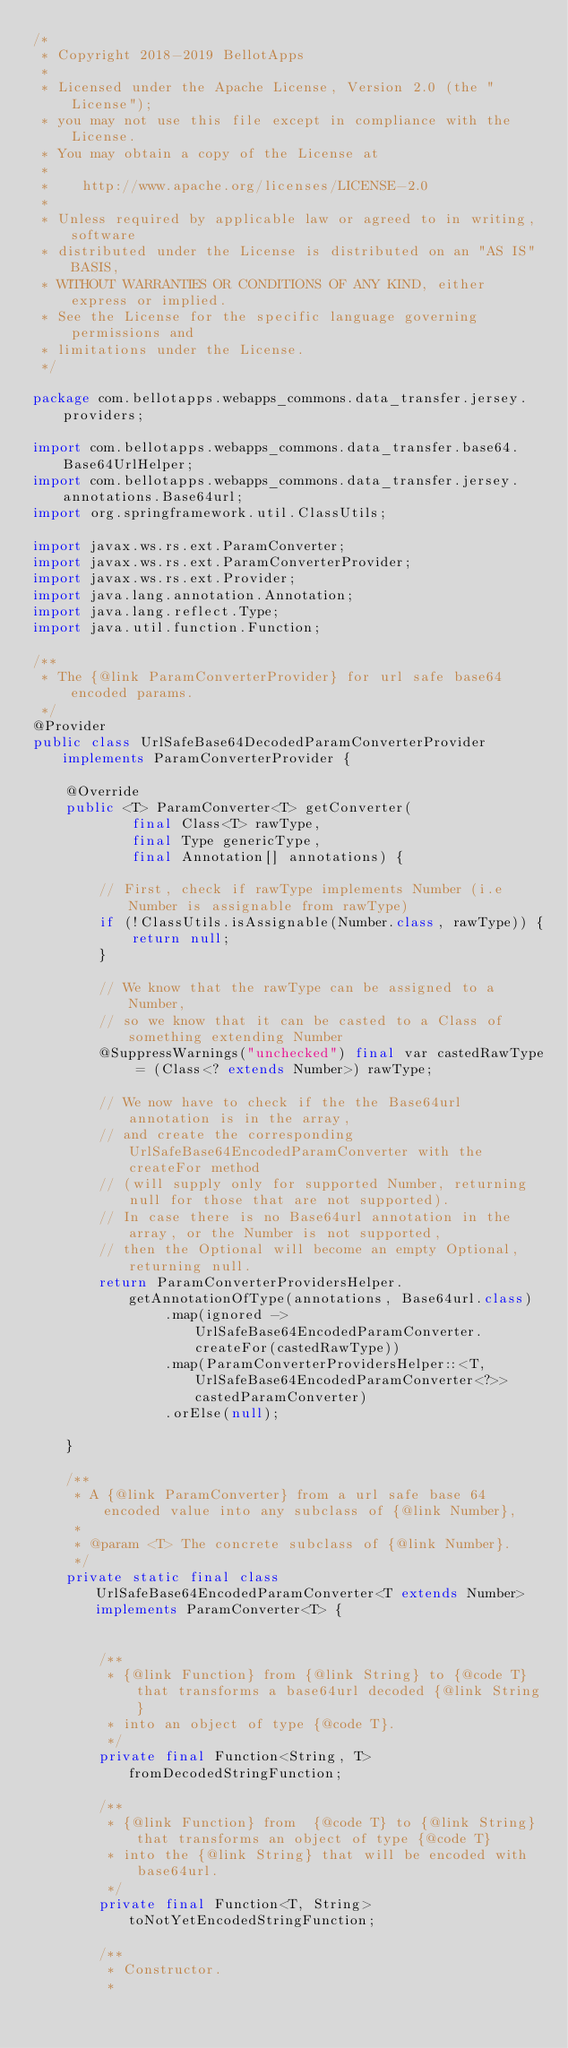<code> <loc_0><loc_0><loc_500><loc_500><_Java_>/*
 * Copyright 2018-2019 BellotApps
 *
 * Licensed under the Apache License, Version 2.0 (the "License");
 * you may not use this file except in compliance with the License.
 * You may obtain a copy of the License at
 *
 *    http://www.apache.org/licenses/LICENSE-2.0
 *
 * Unless required by applicable law or agreed to in writing, software
 * distributed under the License is distributed on an "AS IS" BASIS,
 * WITHOUT WARRANTIES OR CONDITIONS OF ANY KIND, either express or implied.
 * See the License for the specific language governing permissions and
 * limitations under the License.
 */

package com.bellotapps.webapps_commons.data_transfer.jersey.providers;

import com.bellotapps.webapps_commons.data_transfer.base64.Base64UrlHelper;
import com.bellotapps.webapps_commons.data_transfer.jersey.annotations.Base64url;
import org.springframework.util.ClassUtils;

import javax.ws.rs.ext.ParamConverter;
import javax.ws.rs.ext.ParamConverterProvider;
import javax.ws.rs.ext.Provider;
import java.lang.annotation.Annotation;
import java.lang.reflect.Type;
import java.util.function.Function;

/**
 * The {@link ParamConverterProvider} for url safe base64 encoded params.
 */
@Provider
public class UrlSafeBase64DecodedParamConverterProvider implements ParamConverterProvider {

    @Override
    public <T> ParamConverter<T> getConverter(
            final Class<T> rawType,
            final Type genericType,
            final Annotation[] annotations) {

        // First, check if rawType implements Number (i.e Number is assignable from rawType)
        if (!ClassUtils.isAssignable(Number.class, rawType)) {
            return null;
        }

        // We know that the rawType can be assigned to a Number,
        // so we know that it can be casted to a Class of something extending Number
        @SuppressWarnings("unchecked") final var castedRawType = (Class<? extends Number>) rawType;

        // We now have to check if the the Base64url annotation is in the array,
        // and create the corresponding UrlSafeBase64EncodedParamConverter with the createFor method
        // (will supply only for supported Number, returning null for those that are not supported).
        // In case there is no Base64url annotation in the array, or the Number is not supported,
        // then the Optional will become an empty Optional, returning null.
        return ParamConverterProvidersHelper.getAnnotationOfType(annotations, Base64url.class)
                .map(ignored -> UrlSafeBase64EncodedParamConverter.createFor(castedRawType))
                .map(ParamConverterProvidersHelper::<T, UrlSafeBase64EncodedParamConverter<?>>castedParamConverter)
                .orElse(null);

    }

    /**
     * A {@link ParamConverter} from a url safe base 64 encoded value into any subclass of {@link Number},
     *
     * @param <T> The concrete subclass of {@link Number}.
     */
    private static final class UrlSafeBase64EncodedParamConverter<T extends Number> implements ParamConverter<T> {


        /**
         * {@link Function} from {@link String} to {@code T} that transforms a base64url decoded {@link String}
         * into an object of type {@code T}.
         */
        private final Function<String, T> fromDecodedStringFunction;

        /**
         * {@link Function} from  {@code T} to {@link String} that transforms an object of type {@code T}
         * into the {@link String} that will be encoded with base64url.
         */
        private final Function<T, String> toNotYetEncodedStringFunction;

        /**
         * Constructor.
         *</code> 